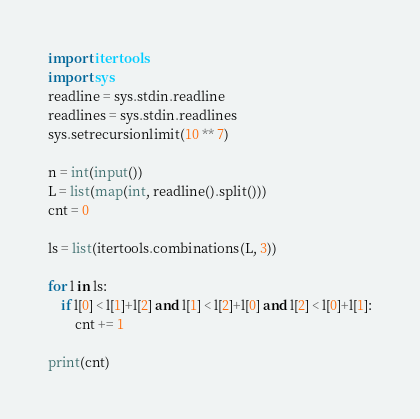<code> <loc_0><loc_0><loc_500><loc_500><_Python_>import itertools
import sys
readline = sys.stdin.readline
readlines = sys.stdin.readlines
sys.setrecursionlimit(10 ** 7)

n = int(input())
L = list(map(int, readline().split()))
cnt = 0

ls = list(itertools.combinations(L, 3))

for l in ls:
    if l[0] < l[1]+l[2] and l[1] < l[2]+l[0] and l[2] < l[0]+l[1]:
        cnt += 1

print(cnt)
</code> 